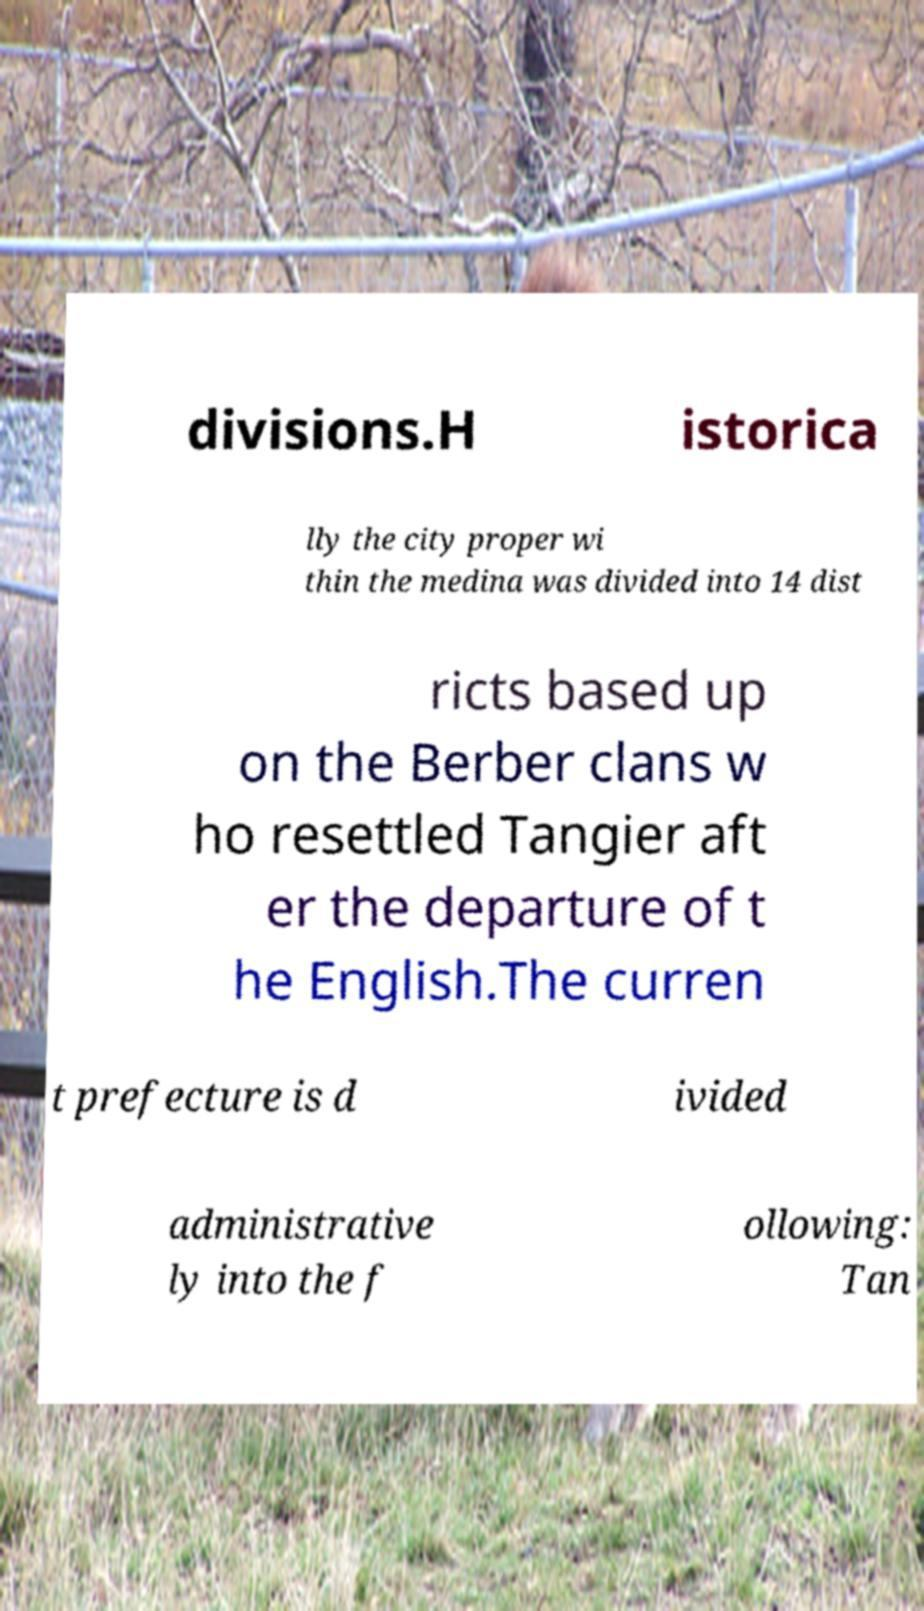Can you read and provide the text displayed in the image?This photo seems to have some interesting text. Can you extract and type it out for me? divisions.H istorica lly the city proper wi thin the medina was divided into 14 dist ricts based up on the Berber clans w ho resettled Tangier aft er the departure of t he English.The curren t prefecture is d ivided administrative ly into the f ollowing: Tan 